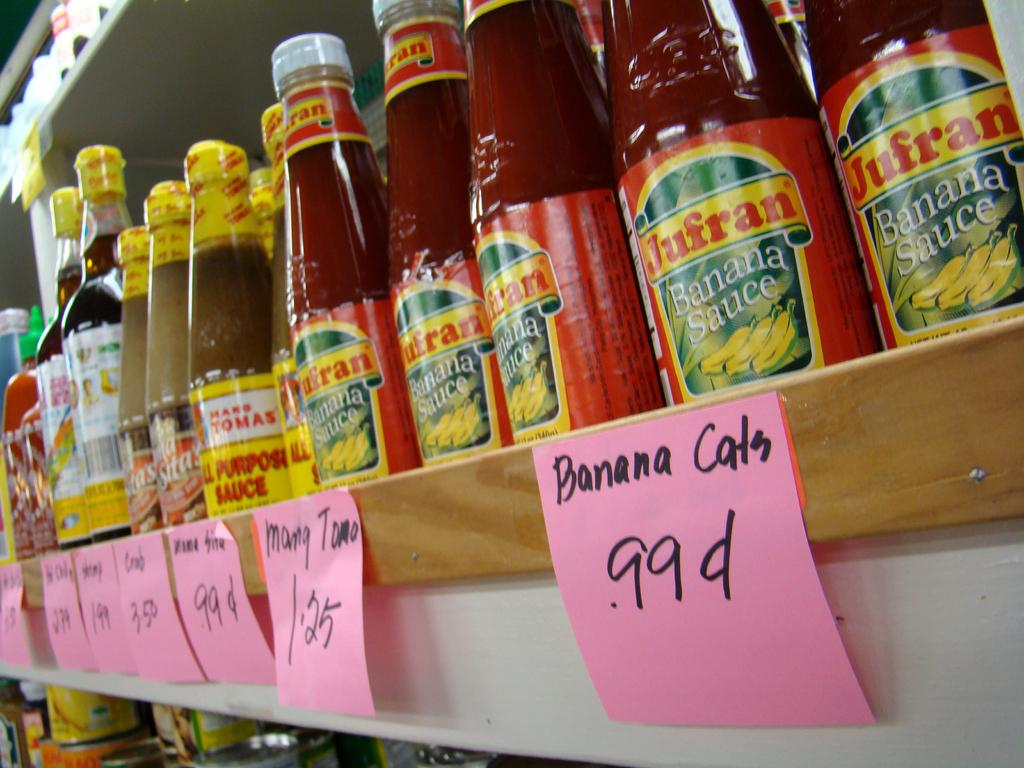<image>
Create a compact narrative representing the image presented. the word banana is on the pink sticky note 